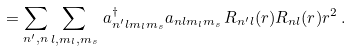<formula> <loc_0><loc_0><loc_500><loc_500>= \sum _ { n ^ { \prime } , n } \sum _ { l , m _ { l } , m _ { s } } \, a ^ { \dag } _ { n ^ { \prime } l m _ { l } m _ { s } } a _ { n l m _ { l } m _ { s } } \, R _ { n ^ { \prime } l } ( r ) R _ { n l } ( r ) r ^ { 2 } \, .</formula> 